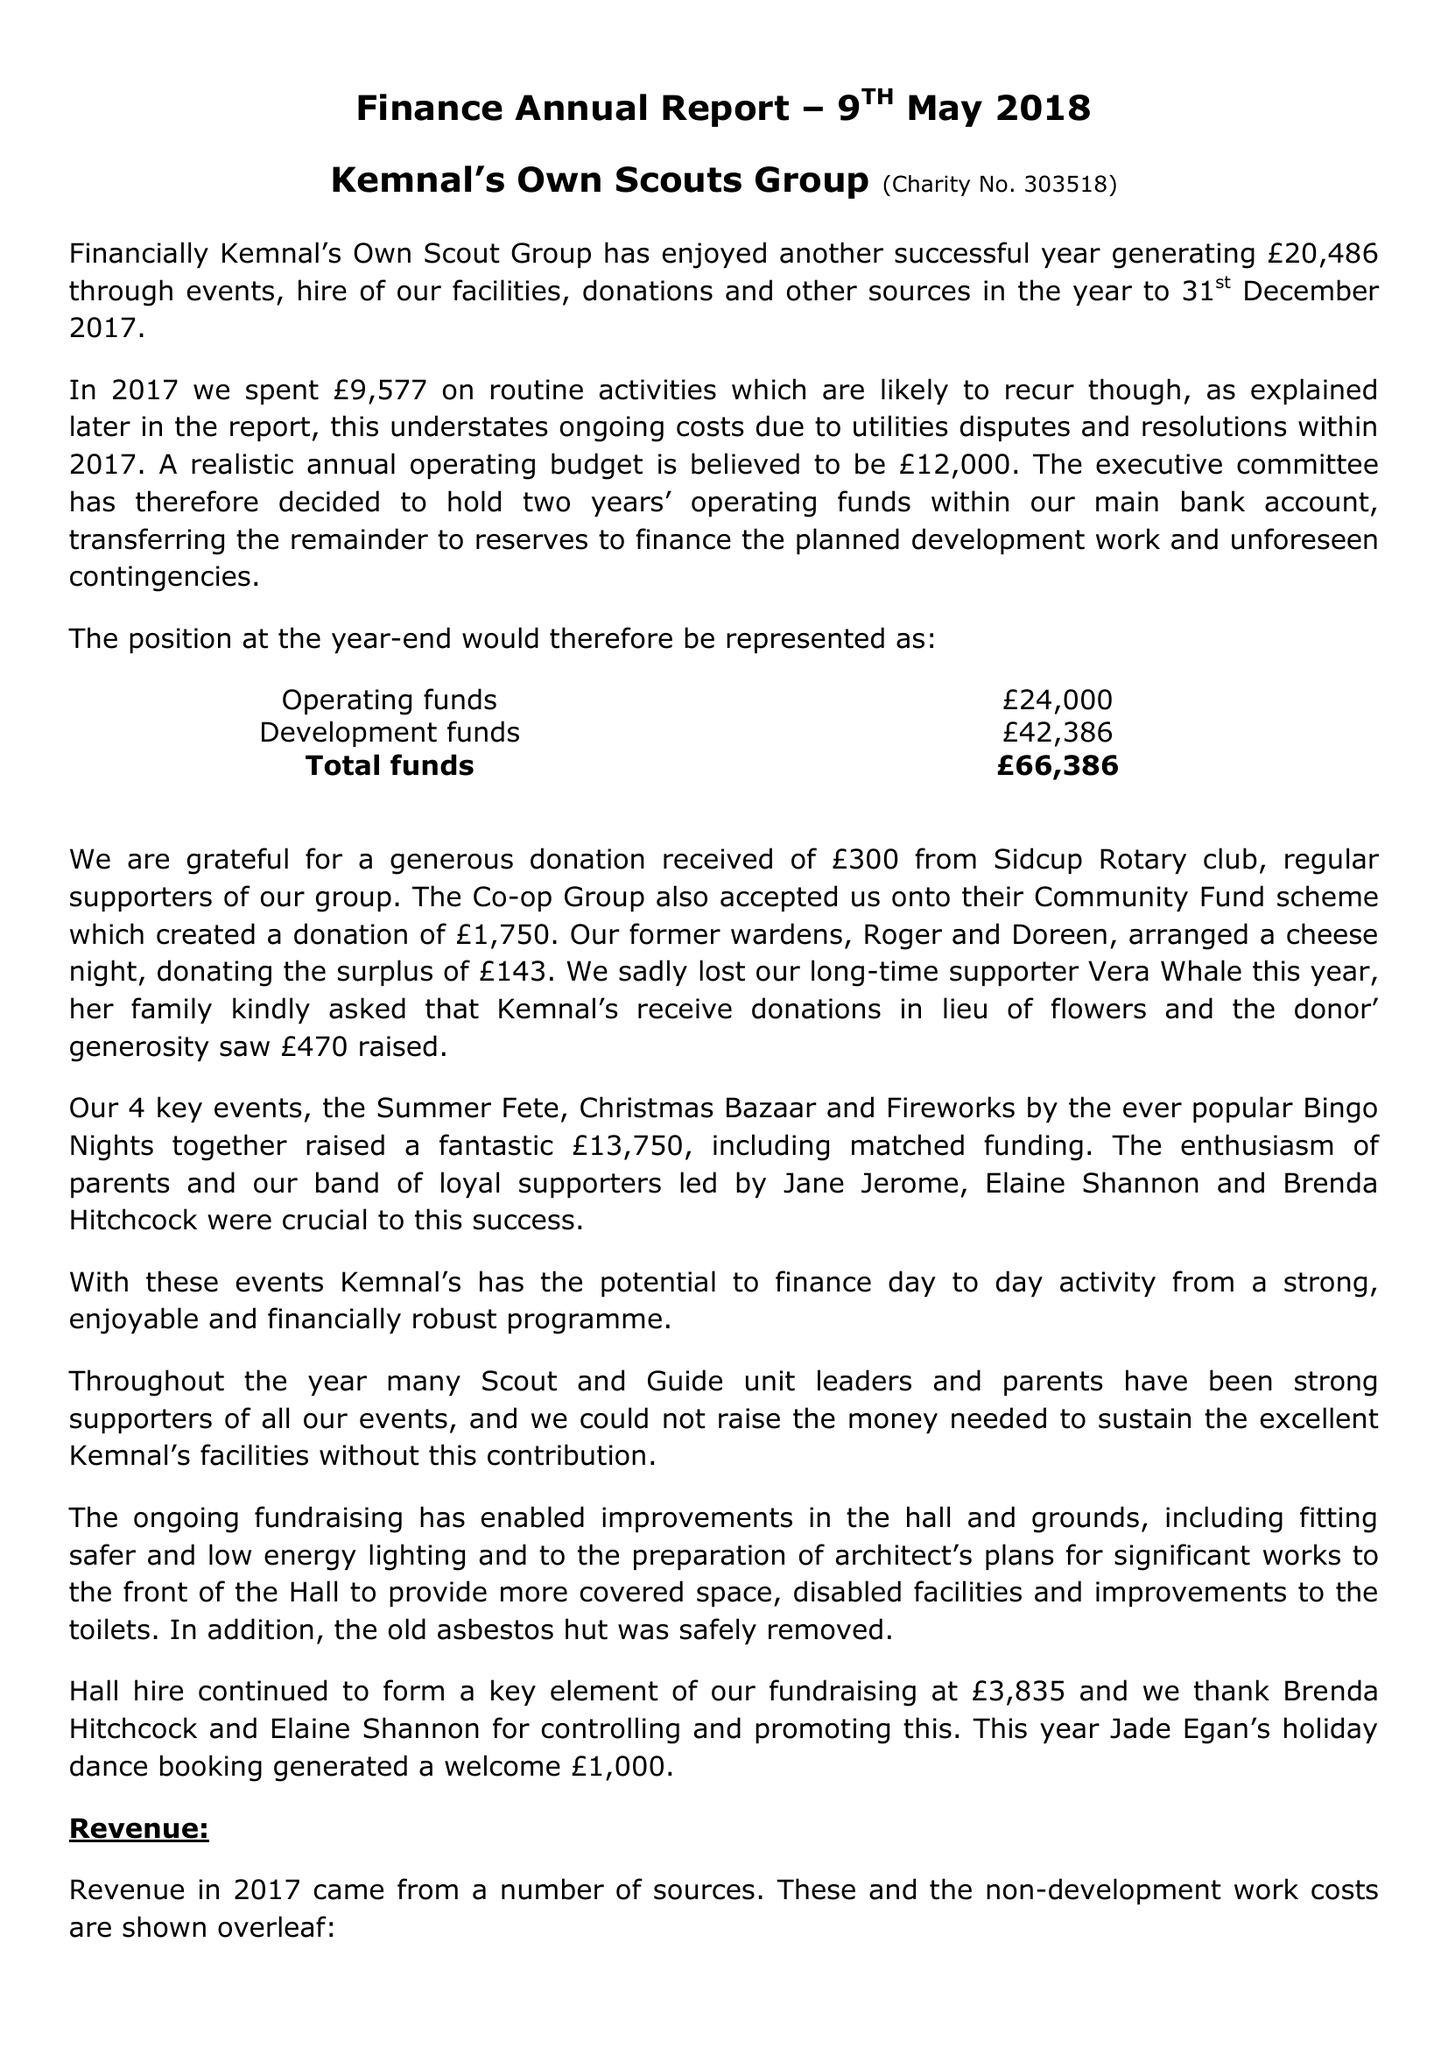What is the value for the charity_number?
Answer the question using a single word or phrase. 303518 